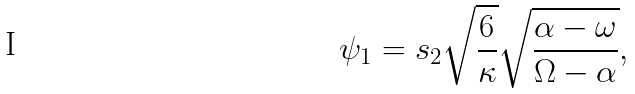Convert formula to latex. <formula><loc_0><loc_0><loc_500><loc_500>\psi _ { 1 } = s _ { 2 } \sqrt { \frac { 6 } { \kappa } } \sqrt { \frac { \alpha - \omega } { \Omega - \alpha } } ,</formula> 